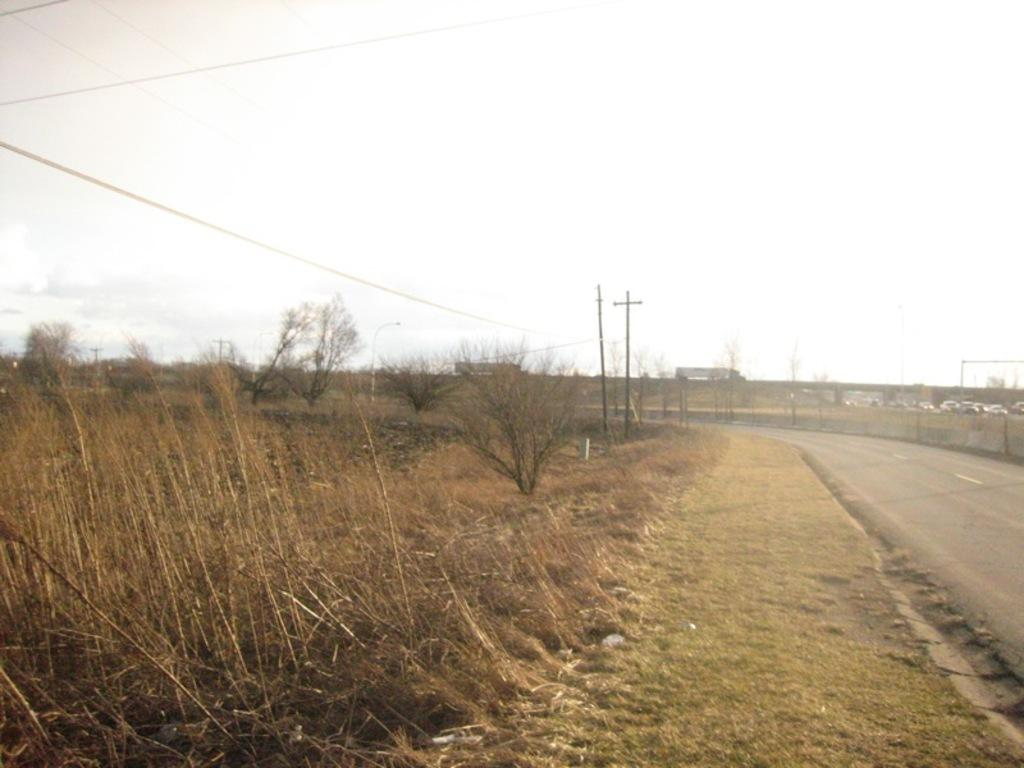What type of surface is located on the right side of the image? There is a road on the right side of the image. What can be seen on the left side of the image? There is land on the left side of the image. What type of vegetation is present on the land? Grass is present on the land. What structures are visible on the footpath in the image? There are two electric poles on the footpath. What is visible at the top of the image? The sky is visible at the top of the image. Where is the hydrant located in the image? There is no hydrant present in the image. What type of bomb is depicted in the image? There is no bomb present in the image. 